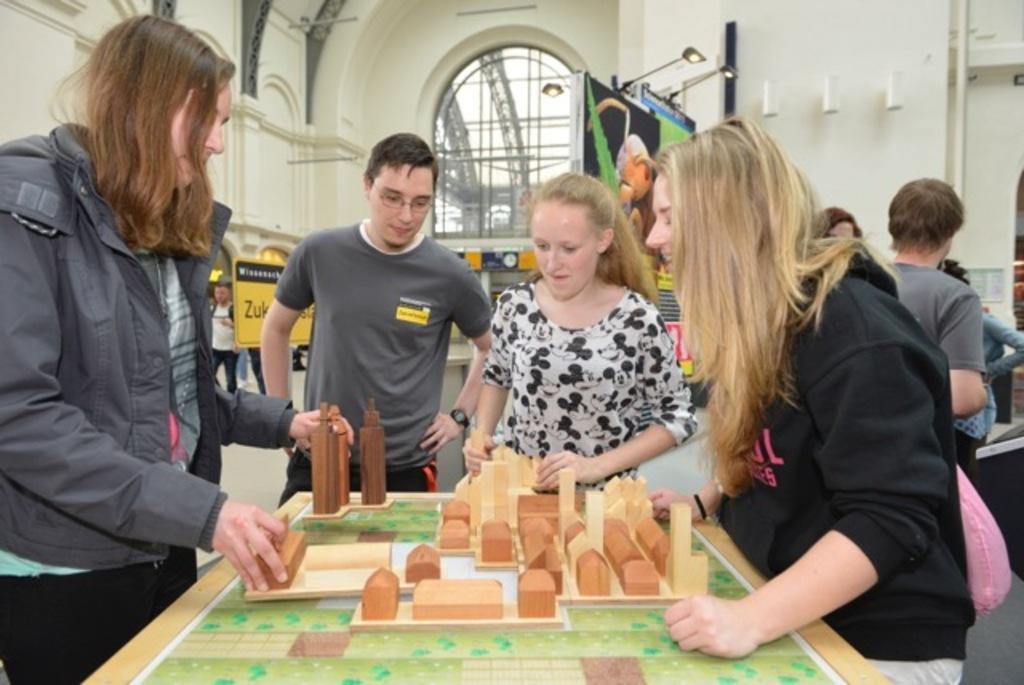Describe this image in one or two sentences. In the image we can see there are people who are standing. 